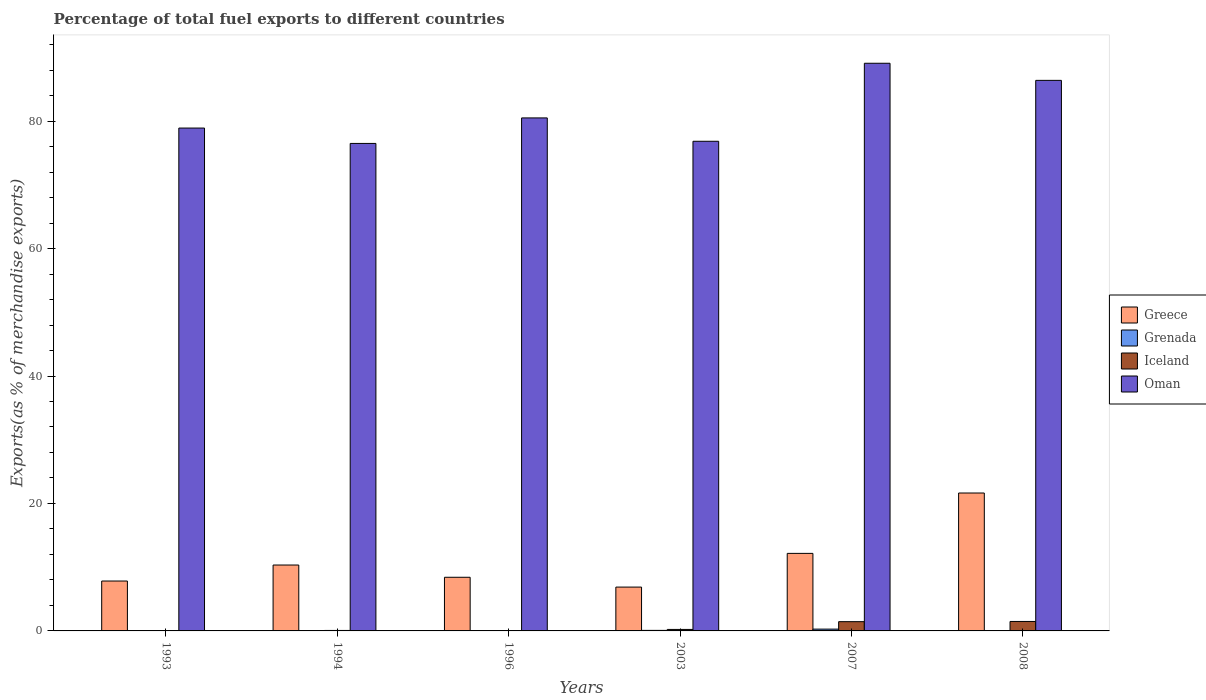Are the number of bars on each tick of the X-axis equal?
Keep it short and to the point. Yes. What is the percentage of exports to different countries in Iceland in 1994?
Make the answer very short. 0.07. Across all years, what is the maximum percentage of exports to different countries in Oman?
Offer a very short reply. 89.07. Across all years, what is the minimum percentage of exports to different countries in Iceland?
Give a very brief answer. 0.05. In which year was the percentage of exports to different countries in Oman maximum?
Keep it short and to the point. 2007. In which year was the percentage of exports to different countries in Grenada minimum?
Your answer should be very brief. 1993. What is the total percentage of exports to different countries in Greece in the graph?
Make the answer very short. 67.28. What is the difference between the percentage of exports to different countries in Grenada in 1994 and that in 2008?
Your answer should be very brief. -0.03. What is the difference between the percentage of exports to different countries in Grenada in 2007 and the percentage of exports to different countries in Greece in 1993?
Give a very brief answer. -7.55. What is the average percentage of exports to different countries in Grenada per year?
Ensure brevity in your answer.  0.07. In the year 1994, what is the difference between the percentage of exports to different countries in Greece and percentage of exports to different countries in Iceland?
Your answer should be very brief. 10.27. In how many years, is the percentage of exports to different countries in Grenada greater than 4 %?
Your response must be concise. 0. What is the ratio of the percentage of exports to different countries in Grenada in 1994 to that in 2008?
Offer a very short reply. 0.25. Is the difference between the percentage of exports to different countries in Greece in 2003 and 2007 greater than the difference between the percentage of exports to different countries in Iceland in 2003 and 2007?
Offer a terse response. No. What is the difference between the highest and the second highest percentage of exports to different countries in Grenada?
Make the answer very short. 0.2. What is the difference between the highest and the lowest percentage of exports to different countries in Greece?
Your response must be concise. 14.76. In how many years, is the percentage of exports to different countries in Grenada greater than the average percentage of exports to different countries in Grenada taken over all years?
Offer a terse response. 2. What does the 1st bar from the left in 1993 represents?
Provide a succinct answer. Greece. What does the 3rd bar from the right in 1993 represents?
Your response must be concise. Grenada. Is it the case that in every year, the sum of the percentage of exports to different countries in Grenada and percentage of exports to different countries in Iceland is greater than the percentage of exports to different countries in Greece?
Your answer should be compact. No. Are all the bars in the graph horizontal?
Make the answer very short. No. Are the values on the major ticks of Y-axis written in scientific E-notation?
Keep it short and to the point. No. Does the graph contain grids?
Your answer should be compact. No. Where does the legend appear in the graph?
Provide a short and direct response. Center right. What is the title of the graph?
Give a very brief answer. Percentage of total fuel exports to different countries. What is the label or title of the Y-axis?
Keep it short and to the point. Exports(as % of merchandise exports). What is the Exports(as % of merchandise exports) of Greece in 1993?
Your answer should be very brief. 7.83. What is the Exports(as % of merchandise exports) of Grenada in 1993?
Make the answer very short. 0. What is the Exports(as % of merchandise exports) in Iceland in 1993?
Provide a short and direct response. 0.05. What is the Exports(as % of merchandise exports) of Oman in 1993?
Provide a short and direct response. 78.91. What is the Exports(as % of merchandise exports) in Greece in 1994?
Give a very brief answer. 10.34. What is the Exports(as % of merchandise exports) of Grenada in 1994?
Keep it short and to the point. 0.01. What is the Exports(as % of merchandise exports) of Iceland in 1994?
Give a very brief answer. 0.07. What is the Exports(as % of merchandise exports) in Oman in 1994?
Provide a succinct answer. 76.5. What is the Exports(as % of merchandise exports) in Greece in 1996?
Your answer should be compact. 8.42. What is the Exports(as % of merchandise exports) in Grenada in 1996?
Ensure brevity in your answer.  0.03. What is the Exports(as % of merchandise exports) in Iceland in 1996?
Your response must be concise. 0.06. What is the Exports(as % of merchandise exports) in Oman in 1996?
Your answer should be very brief. 80.5. What is the Exports(as % of merchandise exports) of Greece in 2003?
Offer a very short reply. 6.88. What is the Exports(as % of merchandise exports) in Grenada in 2003?
Your answer should be very brief. 0.08. What is the Exports(as % of merchandise exports) in Iceland in 2003?
Keep it short and to the point. 0.23. What is the Exports(as % of merchandise exports) in Oman in 2003?
Your answer should be very brief. 76.83. What is the Exports(as % of merchandise exports) in Greece in 2007?
Offer a terse response. 12.17. What is the Exports(as % of merchandise exports) of Grenada in 2007?
Provide a succinct answer. 0.28. What is the Exports(as % of merchandise exports) of Iceland in 2007?
Offer a terse response. 1.45. What is the Exports(as % of merchandise exports) in Oman in 2007?
Make the answer very short. 89.07. What is the Exports(as % of merchandise exports) of Greece in 2008?
Make the answer very short. 21.64. What is the Exports(as % of merchandise exports) in Grenada in 2008?
Offer a terse response. 0.03. What is the Exports(as % of merchandise exports) in Iceland in 2008?
Your answer should be very brief. 1.48. What is the Exports(as % of merchandise exports) in Oman in 2008?
Your response must be concise. 86.39. Across all years, what is the maximum Exports(as % of merchandise exports) in Greece?
Keep it short and to the point. 21.64. Across all years, what is the maximum Exports(as % of merchandise exports) in Grenada?
Give a very brief answer. 0.28. Across all years, what is the maximum Exports(as % of merchandise exports) of Iceland?
Provide a short and direct response. 1.48. Across all years, what is the maximum Exports(as % of merchandise exports) of Oman?
Your response must be concise. 89.07. Across all years, what is the minimum Exports(as % of merchandise exports) in Greece?
Give a very brief answer. 6.88. Across all years, what is the minimum Exports(as % of merchandise exports) in Grenada?
Offer a terse response. 0. Across all years, what is the minimum Exports(as % of merchandise exports) in Iceland?
Give a very brief answer. 0.05. Across all years, what is the minimum Exports(as % of merchandise exports) in Oman?
Your answer should be very brief. 76.5. What is the total Exports(as % of merchandise exports) of Greece in the graph?
Give a very brief answer. 67.28. What is the total Exports(as % of merchandise exports) of Grenada in the graph?
Make the answer very short. 0.44. What is the total Exports(as % of merchandise exports) of Iceland in the graph?
Your answer should be very brief. 3.36. What is the total Exports(as % of merchandise exports) of Oman in the graph?
Your answer should be very brief. 488.2. What is the difference between the Exports(as % of merchandise exports) in Greece in 1993 and that in 1994?
Give a very brief answer. -2.51. What is the difference between the Exports(as % of merchandise exports) of Grenada in 1993 and that in 1994?
Give a very brief answer. -0.01. What is the difference between the Exports(as % of merchandise exports) in Iceland in 1993 and that in 1994?
Make the answer very short. -0.02. What is the difference between the Exports(as % of merchandise exports) in Oman in 1993 and that in 1994?
Make the answer very short. 2.41. What is the difference between the Exports(as % of merchandise exports) in Greece in 1993 and that in 1996?
Offer a terse response. -0.59. What is the difference between the Exports(as % of merchandise exports) in Grenada in 1993 and that in 1996?
Your answer should be very brief. -0.03. What is the difference between the Exports(as % of merchandise exports) in Iceland in 1993 and that in 1996?
Give a very brief answer. -0.01. What is the difference between the Exports(as % of merchandise exports) in Oman in 1993 and that in 1996?
Your answer should be very brief. -1.59. What is the difference between the Exports(as % of merchandise exports) of Greece in 1993 and that in 2003?
Your answer should be very brief. 0.95. What is the difference between the Exports(as % of merchandise exports) in Grenada in 1993 and that in 2003?
Your response must be concise. -0.08. What is the difference between the Exports(as % of merchandise exports) of Iceland in 1993 and that in 2003?
Offer a very short reply. -0.18. What is the difference between the Exports(as % of merchandise exports) in Oman in 1993 and that in 2003?
Ensure brevity in your answer.  2.07. What is the difference between the Exports(as % of merchandise exports) in Greece in 1993 and that in 2007?
Provide a succinct answer. -4.34. What is the difference between the Exports(as % of merchandise exports) in Grenada in 1993 and that in 2007?
Your response must be concise. -0.28. What is the difference between the Exports(as % of merchandise exports) in Iceland in 1993 and that in 2007?
Keep it short and to the point. -1.4. What is the difference between the Exports(as % of merchandise exports) of Oman in 1993 and that in 2007?
Provide a succinct answer. -10.17. What is the difference between the Exports(as % of merchandise exports) of Greece in 1993 and that in 2008?
Provide a succinct answer. -13.81. What is the difference between the Exports(as % of merchandise exports) of Grenada in 1993 and that in 2008?
Your response must be concise. -0.03. What is the difference between the Exports(as % of merchandise exports) of Iceland in 1993 and that in 2008?
Give a very brief answer. -1.43. What is the difference between the Exports(as % of merchandise exports) in Oman in 1993 and that in 2008?
Offer a very short reply. -7.48. What is the difference between the Exports(as % of merchandise exports) in Greece in 1994 and that in 1996?
Provide a succinct answer. 1.92. What is the difference between the Exports(as % of merchandise exports) of Grenada in 1994 and that in 1996?
Your answer should be compact. -0.02. What is the difference between the Exports(as % of merchandise exports) of Iceland in 1994 and that in 1996?
Give a very brief answer. 0.01. What is the difference between the Exports(as % of merchandise exports) of Oman in 1994 and that in 1996?
Your answer should be very brief. -4. What is the difference between the Exports(as % of merchandise exports) of Greece in 1994 and that in 2003?
Offer a very short reply. 3.46. What is the difference between the Exports(as % of merchandise exports) in Grenada in 1994 and that in 2003?
Give a very brief answer. -0.08. What is the difference between the Exports(as % of merchandise exports) in Iceland in 1994 and that in 2003?
Your answer should be very brief. -0.16. What is the difference between the Exports(as % of merchandise exports) in Oman in 1994 and that in 2003?
Your answer should be compact. -0.34. What is the difference between the Exports(as % of merchandise exports) in Greece in 1994 and that in 2007?
Provide a succinct answer. -1.83. What is the difference between the Exports(as % of merchandise exports) in Grenada in 1994 and that in 2007?
Your answer should be very brief. -0.27. What is the difference between the Exports(as % of merchandise exports) in Iceland in 1994 and that in 2007?
Provide a succinct answer. -1.38. What is the difference between the Exports(as % of merchandise exports) in Oman in 1994 and that in 2007?
Your answer should be compact. -12.58. What is the difference between the Exports(as % of merchandise exports) of Greece in 1994 and that in 2008?
Your answer should be very brief. -11.3. What is the difference between the Exports(as % of merchandise exports) of Grenada in 1994 and that in 2008?
Give a very brief answer. -0.03. What is the difference between the Exports(as % of merchandise exports) in Iceland in 1994 and that in 2008?
Ensure brevity in your answer.  -1.41. What is the difference between the Exports(as % of merchandise exports) in Oman in 1994 and that in 2008?
Offer a very short reply. -9.89. What is the difference between the Exports(as % of merchandise exports) in Greece in 1996 and that in 2003?
Provide a succinct answer. 1.54. What is the difference between the Exports(as % of merchandise exports) of Grenada in 1996 and that in 2003?
Offer a terse response. -0.06. What is the difference between the Exports(as % of merchandise exports) of Iceland in 1996 and that in 2003?
Ensure brevity in your answer.  -0.17. What is the difference between the Exports(as % of merchandise exports) of Oman in 1996 and that in 2003?
Your answer should be very brief. 3.67. What is the difference between the Exports(as % of merchandise exports) of Greece in 1996 and that in 2007?
Your response must be concise. -3.75. What is the difference between the Exports(as % of merchandise exports) of Grenada in 1996 and that in 2007?
Ensure brevity in your answer.  -0.25. What is the difference between the Exports(as % of merchandise exports) in Iceland in 1996 and that in 2007?
Your answer should be very brief. -1.39. What is the difference between the Exports(as % of merchandise exports) in Oman in 1996 and that in 2007?
Give a very brief answer. -8.58. What is the difference between the Exports(as % of merchandise exports) in Greece in 1996 and that in 2008?
Your answer should be compact. -13.22. What is the difference between the Exports(as % of merchandise exports) of Grenada in 1996 and that in 2008?
Your answer should be very brief. -0.01. What is the difference between the Exports(as % of merchandise exports) of Iceland in 1996 and that in 2008?
Offer a very short reply. -1.42. What is the difference between the Exports(as % of merchandise exports) of Oman in 1996 and that in 2008?
Provide a short and direct response. -5.89. What is the difference between the Exports(as % of merchandise exports) of Greece in 2003 and that in 2007?
Your answer should be very brief. -5.29. What is the difference between the Exports(as % of merchandise exports) in Grenada in 2003 and that in 2007?
Ensure brevity in your answer.  -0.2. What is the difference between the Exports(as % of merchandise exports) in Iceland in 2003 and that in 2007?
Your answer should be compact. -1.22. What is the difference between the Exports(as % of merchandise exports) of Oman in 2003 and that in 2007?
Keep it short and to the point. -12.24. What is the difference between the Exports(as % of merchandise exports) in Greece in 2003 and that in 2008?
Your answer should be compact. -14.76. What is the difference between the Exports(as % of merchandise exports) of Grenada in 2003 and that in 2008?
Provide a succinct answer. 0.05. What is the difference between the Exports(as % of merchandise exports) of Iceland in 2003 and that in 2008?
Your response must be concise. -1.25. What is the difference between the Exports(as % of merchandise exports) of Oman in 2003 and that in 2008?
Provide a short and direct response. -9.56. What is the difference between the Exports(as % of merchandise exports) of Greece in 2007 and that in 2008?
Make the answer very short. -9.47. What is the difference between the Exports(as % of merchandise exports) of Grenada in 2007 and that in 2008?
Offer a very short reply. 0.25. What is the difference between the Exports(as % of merchandise exports) of Iceland in 2007 and that in 2008?
Your answer should be very brief. -0.03. What is the difference between the Exports(as % of merchandise exports) of Oman in 2007 and that in 2008?
Offer a very short reply. 2.69. What is the difference between the Exports(as % of merchandise exports) in Greece in 1993 and the Exports(as % of merchandise exports) in Grenada in 1994?
Ensure brevity in your answer.  7.82. What is the difference between the Exports(as % of merchandise exports) in Greece in 1993 and the Exports(as % of merchandise exports) in Iceland in 1994?
Offer a very short reply. 7.76. What is the difference between the Exports(as % of merchandise exports) of Greece in 1993 and the Exports(as % of merchandise exports) of Oman in 1994?
Your response must be concise. -68.67. What is the difference between the Exports(as % of merchandise exports) of Grenada in 1993 and the Exports(as % of merchandise exports) of Iceland in 1994?
Your answer should be compact. -0.07. What is the difference between the Exports(as % of merchandise exports) of Grenada in 1993 and the Exports(as % of merchandise exports) of Oman in 1994?
Offer a terse response. -76.49. What is the difference between the Exports(as % of merchandise exports) of Iceland in 1993 and the Exports(as % of merchandise exports) of Oman in 1994?
Your answer should be very brief. -76.44. What is the difference between the Exports(as % of merchandise exports) of Greece in 1993 and the Exports(as % of merchandise exports) of Grenada in 1996?
Keep it short and to the point. 7.8. What is the difference between the Exports(as % of merchandise exports) of Greece in 1993 and the Exports(as % of merchandise exports) of Iceland in 1996?
Offer a very short reply. 7.77. What is the difference between the Exports(as % of merchandise exports) in Greece in 1993 and the Exports(as % of merchandise exports) in Oman in 1996?
Make the answer very short. -72.67. What is the difference between the Exports(as % of merchandise exports) of Grenada in 1993 and the Exports(as % of merchandise exports) of Iceland in 1996?
Offer a very short reply. -0.06. What is the difference between the Exports(as % of merchandise exports) of Grenada in 1993 and the Exports(as % of merchandise exports) of Oman in 1996?
Your answer should be very brief. -80.5. What is the difference between the Exports(as % of merchandise exports) in Iceland in 1993 and the Exports(as % of merchandise exports) in Oman in 1996?
Provide a short and direct response. -80.45. What is the difference between the Exports(as % of merchandise exports) of Greece in 1993 and the Exports(as % of merchandise exports) of Grenada in 2003?
Provide a short and direct response. 7.75. What is the difference between the Exports(as % of merchandise exports) in Greece in 1993 and the Exports(as % of merchandise exports) in Iceland in 2003?
Give a very brief answer. 7.59. What is the difference between the Exports(as % of merchandise exports) of Greece in 1993 and the Exports(as % of merchandise exports) of Oman in 2003?
Keep it short and to the point. -69. What is the difference between the Exports(as % of merchandise exports) of Grenada in 1993 and the Exports(as % of merchandise exports) of Iceland in 2003?
Your answer should be compact. -0.23. What is the difference between the Exports(as % of merchandise exports) in Grenada in 1993 and the Exports(as % of merchandise exports) in Oman in 2003?
Your response must be concise. -76.83. What is the difference between the Exports(as % of merchandise exports) in Iceland in 1993 and the Exports(as % of merchandise exports) in Oman in 2003?
Provide a short and direct response. -76.78. What is the difference between the Exports(as % of merchandise exports) in Greece in 1993 and the Exports(as % of merchandise exports) in Grenada in 2007?
Give a very brief answer. 7.55. What is the difference between the Exports(as % of merchandise exports) in Greece in 1993 and the Exports(as % of merchandise exports) in Iceland in 2007?
Offer a very short reply. 6.38. What is the difference between the Exports(as % of merchandise exports) of Greece in 1993 and the Exports(as % of merchandise exports) of Oman in 2007?
Provide a short and direct response. -81.25. What is the difference between the Exports(as % of merchandise exports) of Grenada in 1993 and the Exports(as % of merchandise exports) of Iceland in 2007?
Make the answer very short. -1.45. What is the difference between the Exports(as % of merchandise exports) of Grenada in 1993 and the Exports(as % of merchandise exports) of Oman in 2007?
Provide a short and direct response. -89.07. What is the difference between the Exports(as % of merchandise exports) of Iceland in 1993 and the Exports(as % of merchandise exports) of Oman in 2007?
Your answer should be very brief. -89.02. What is the difference between the Exports(as % of merchandise exports) of Greece in 1993 and the Exports(as % of merchandise exports) of Grenada in 2008?
Your response must be concise. 7.8. What is the difference between the Exports(as % of merchandise exports) of Greece in 1993 and the Exports(as % of merchandise exports) of Iceland in 2008?
Make the answer very short. 6.35. What is the difference between the Exports(as % of merchandise exports) in Greece in 1993 and the Exports(as % of merchandise exports) in Oman in 2008?
Your answer should be very brief. -78.56. What is the difference between the Exports(as % of merchandise exports) in Grenada in 1993 and the Exports(as % of merchandise exports) in Iceland in 2008?
Offer a very short reply. -1.48. What is the difference between the Exports(as % of merchandise exports) of Grenada in 1993 and the Exports(as % of merchandise exports) of Oman in 2008?
Ensure brevity in your answer.  -86.39. What is the difference between the Exports(as % of merchandise exports) in Iceland in 1993 and the Exports(as % of merchandise exports) in Oman in 2008?
Give a very brief answer. -86.34. What is the difference between the Exports(as % of merchandise exports) of Greece in 1994 and the Exports(as % of merchandise exports) of Grenada in 1996?
Make the answer very short. 10.31. What is the difference between the Exports(as % of merchandise exports) of Greece in 1994 and the Exports(as % of merchandise exports) of Iceland in 1996?
Your answer should be very brief. 10.28. What is the difference between the Exports(as % of merchandise exports) of Greece in 1994 and the Exports(as % of merchandise exports) of Oman in 1996?
Your answer should be very brief. -70.16. What is the difference between the Exports(as % of merchandise exports) of Grenada in 1994 and the Exports(as % of merchandise exports) of Iceland in 1996?
Make the answer very short. -0.05. What is the difference between the Exports(as % of merchandise exports) in Grenada in 1994 and the Exports(as % of merchandise exports) in Oman in 1996?
Make the answer very short. -80.49. What is the difference between the Exports(as % of merchandise exports) in Iceland in 1994 and the Exports(as % of merchandise exports) in Oman in 1996?
Your response must be concise. -80.42. What is the difference between the Exports(as % of merchandise exports) of Greece in 1994 and the Exports(as % of merchandise exports) of Grenada in 2003?
Provide a succinct answer. 10.26. What is the difference between the Exports(as % of merchandise exports) in Greece in 1994 and the Exports(as % of merchandise exports) in Iceland in 2003?
Your response must be concise. 10.11. What is the difference between the Exports(as % of merchandise exports) in Greece in 1994 and the Exports(as % of merchandise exports) in Oman in 2003?
Your answer should be compact. -66.49. What is the difference between the Exports(as % of merchandise exports) in Grenada in 1994 and the Exports(as % of merchandise exports) in Iceland in 2003?
Give a very brief answer. -0.23. What is the difference between the Exports(as % of merchandise exports) in Grenada in 1994 and the Exports(as % of merchandise exports) in Oman in 2003?
Your response must be concise. -76.83. What is the difference between the Exports(as % of merchandise exports) of Iceland in 1994 and the Exports(as % of merchandise exports) of Oman in 2003?
Give a very brief answer. -76.76. What is the difference between the Exports(as % of merchandise exports) of Greece in 1994 and the Exports(as % of merchandise exports) of Grenada in 2007?
Your response must be concise. 10.06. What is the difference between the Exports(as % of merchandise exports) in Greece in 1994 and the Exports(as % of merchandise exports) in Iceland in 2007?
Your answer should be compact. 8.89. What is the difference between the Exports(as % of merchandise exports) in Greece in 1994 and the Exports(as % of merchandise exports) in Oman in 2007?
Keep it short and to the point. -78.73. What is the difference between the Exports(as % of merchandise exports) in Grenada in 1994 and the Exports(as % of merchandise exports) in Iceland in 2007?
Ensure brevity in your answer.  -1.45. What is the difference between the Exports(as % of merchandise exports) in Grenada in 1994 and the Exports(as % of merchandise exports) in Oman in 2007?
Offer a very short reply. -89.07. What is the difference between the Exports(as % of merchandise exports) of Iceland in 1994 and the Exports(as % of merchandise exports) of Oman in 2007?
Offer a terse response. -89. What is the difference between the Exports(as % of merchandise exports) of Greece in 1994 and the Exports(as % of merchandise exports) of Grenada in 2008?
Offer a terse response. 10.31. What is the difference between the Exports(as % of merchandise exports) in Greece in 1994 and the Exports(as % of merchandise exports) in Iceland in 2008?
Your answer should be compact. 8.86. What is the difference between the Exports(as % of merchandise exports) in Greece in 1994 and the Exports(as % of merchandise exports) in Oman in 2008?
Provide a succinct answer. -76.05. What is the difference between the Exports(as % of merchandise exports) in Grenada in 1994 and the Exports(as % of merchandise exports) in Iceland in 2008?
Provide a short and direct response. -1.47. What is the difference between the Exports(as % of merchandise exports) of Grenada in 1994 and the Exports(as % of merchandise exports) of Oman in 2008?
Provide a short and direct response. -86.38. What is the difference between the Exports(as % of merchandise exports) of Iceland in 1994 and the Exports(as % of merchandise exports) of Oman in 2008?
Give a very brief answer. -86.32. What is the difference between the Exports(as % of merchandise exports) in Greece in 1996 and the Exports(as % of merchandise exports) in Grenada in 2003?
Ensure brevity in your answer.  8.34. What is the difference between the Exports(as % of merchandise exports) in Greece in 1996 and the Exports(as % of merchandise exports) in Iceland in 2003?
Your answer should be very brief. 8.18. What is the difference between the Exports(as % of merchandise exports) in Greece in 1996 and the Exports(as % of merchandise exports) in Oman in 2003?
Provide a short and direct response. -68.41. What is the difference between the Exports(as % of merchandise exports) in Grenada in 1996 and the Exports(as % of merchandise exports) in Iceland in 2003?
Your response must be concise. -0.21. What is the difference between the Exports(as % of merchandise exports) of Grenada in 1996 and the Exports(as % of merchandise exports) of Oman in 2003?
Offer a very short reply. -76.81. What is the difference between the Exports(as % of merchandise exports) in Iceland in 1996 and the Exports(as % of merchandise exports) in Oman in 2003?
Offer a very short reply. -76.77. What is the difference between the Exports(as % of merchandise exports) of Greece in 1996 and the Exports(as % of merchandise exports) of Grenada in 2007?
Your answer should be compact. 8.14. What is the difference between the Exports(as % of merchandise exports) of Greece in 1996 and the Exports(as % of merchandise exports) of Iceland in 2007?
Your answer should be very brief. 6.97. What is the difference between the Exports(as % of merchandise exports) in Greece in 1996 and the Exports(as % of merchandise exports) in Oman in 2007?
Your answer should be compact. -80.66. What is the difference between the Exports(as % of merchandise exports) in Grenada in 1996 and the Exports(as % of merchandise exports) in Iceland in 2007?
Your answer should be compact. -1.43. What is the difference between the Exports(as % of merchandise exports) in Grenada in 1996 and the Exports(as % of merchandise exports) in Oman in 2007?
Provide a succinct answer. -89.05. What is the difference between the Exports(as % of merchandise exports) in Iceland in 1996 and the Exports(as % of merchandise exports) in Oman in 2007?
Provide a succinct answer. -89.01. What is the difference between the Exports(as % of merchandise exports) of Greece in 1996 and the Exports(as % of merchandise exports) of Grenada in 2008?
Make the answer very short. 8.39. What is the difference between the Exports(as % of merchandise exports) of Greece in 1996 and the Exports(as % of merchandise exports) of Iceland in 2008?
Your answer should be very brief. 6.94. What is the difference between the Exports(as % of merchandise exports) of Greece in 1996 and the Exports(as % of merchandise exports) of Oman in 2008?
Keep it short and to the point. -77.97. What is the difference between the Exports(as % of merchandise exports) of Grenada in 1996 and the Exports(as % of merchandise exports) of Iceland in 2008?
Provide a short and direct response. -1.46. What is the difference between the Exports(as % of merchandise exports) in Grenada in 1996 and the Exports(as % of merchandise exports) in Oman in 2008?
Give a very brief answer. -86.36. What is the difference between the Exports(as % of merchandise exports) in Iceland in 1996 and the Exports(as % of merchandise exports) in Oman in 2008?
Provide a short and direct response. -86.33. What is the difference between the Exports(as % of merchandise exports) of Greece in 2003 and the Exports(as % of merchandise exports) of Grenada in 2007?
Your response must be concise. 6.6. What is the difference between the Exports(as % of merchandise exports) in Greece in 2003 and the Exports(as % of merchandise exports) in Iceland in 2007?
Ensure brevity in your answer.  5.42. What is the difference between the Exports(as % of merchandise exports) in Greece in 2003 and the Exports(as % of merchandise exports) in Oman in 2007?
Make the answer very short. -82.2. What is the difference between the Exports(as % of merchandise exports) in Grenada in 2003 and the Exports(as % of merchandise exports) in Iceland in 2007?
Offer a terse response. -1.37. What is the difference between the Exports(as % of merchandise exports) in Grenada in 2003 and the Exports(as % of merchandise exports) in Oman in 2007?
Make the answer very short. -88.99. What is the difference between the Exports(as % of merchandise exports) of Iceland in 2003 and the Exports(as % of merchandise exports) of Oman in 2007?
Ensure brevity in your answer.  -88.84. What is the difference between the Exports(as % of merchandise exports) of Greece in 2003 and the Exports(as % of merchandise exports) of Grenada in 2008?
Ensure brevity in your answer.  6.84. What is the difference between the Exports(as % of merchandise exports) in Greece in 2003 and the Exports(as % of merchandise exports) in Iceland in 2008?
Your answer should be very brief. 5.4. What is the difference between the Exports(as % of merchandise exports) in Greece in 2003 and the Exports(as % of merchandise exports) in Oman in 2008?
Your response must be concise. -79.51. What is the difference between the Exports(as % of merchandise exports) of Grenada in 2003 and the Exports(as % of merchandise exports) of Iceland in 2008?
Make the answer very short. -1.4. What is the difference between the Exports(as % of merchandise exports) of Grenada in 2003 and the Exports(as % of merchandise exports) of Oman in 2008?
Ensure brevity in your answer.  -86.31. What is the difference between the Exports(as % of merchandise exports) of Iceland in 2003 and the Exports(as % of merchandise exports) of Oman in 2008?
Give a very brief answer. -86.15. What is the difference between the Exports(as % of merchandise exports) of Greece in 2007 and the Exports(as % of merchandise exports) of Grenada in 2008?
Offer a very short reply. 12.13. What is the difference between the Exports(as % of merchandise exports) of Greece in 2007 and the Exports(as % of merchandise exports) of Iceland in 2008?
Provide a succinct answer. 10.68. What is the difference between the Exports(as % of merchandise exports) in Greece in 2007 and the Exports(as % of merchandise exports) in Oman in 2008?
Provide a short and direct response. -74.22. What is the difference between the Exports(as % of merchandise exports) of Grenada in 2007 and the Exports(as % of merchandise exports) of Iceland in 2008?
Your response must be concise. -1.2. What is the difference between the Exports(as % of merchandise exports) in Grenada in 2007 and the Exports(as % of merchandise exports) in Oman in 2008?
Offer a very short reply. -86.11. What is the difference between the Exports(as % of merchandise exports) in Iceland in 2007 and the Exports(as % of merchandise exports) in Oman in 2008?
Provide a succinct answer. -84.94. What is the average Exports(as % of merchandise exports) in Greece per year?
Make the answer very short. 11.21. What is the average Exports(as % of merchandise exports) of Grenada per year?
Your answer should be very brief. 0.07. What is the average Exports(as % of merchandise exports) of Iceland per year?
Keep it short and to the point. 0.56. What is the average Exports(as % of merchandise exports) in Oman per year?
Offer a very short reply. 81.37. In the year 1993, what is the difference between the Exports(as % of merchandise exports) of Greece and Exports(as % of merchandise exports) of Grenada?
Ensure brevity in your answer.  7.83. In the year 1993, what is the difference between the Exports(as % of merchandise exports) in Greece and Exports(as % of merchandise exports) in Iceland?
Make the answer very short. 7.78. In the year 1993, what is the difference between the Exports(as % of merchandise exports) in Greece and Exports(as % of merchandise exports) in Oman?
Ensure brevity in your answer.  -71.08. In the year 1993, what is the difference between the Exports(as % of merchandise exports) of Grenada and Exports(as % of merchandise exports) of Iceland?
Keep it short and to the point. -0.05. In the year 1993, what is the difference between the Exports(as % of merchandise exports) in Grenada and Exports(as % of merchandise exports) in Oman?
Provide a short and direct response. -78.91. In the year 1993, what is the difference between the Exports(as % of merchandise exports) in Iceland and Exports(as % of merchandise exports) in Oman?
Provide a short and direct response. -78.86. In the year 1994, what is the difference between the Exports(as % of merchandise exports) in Greece and Exports(as % of merchandise exports) in Grenada?
Keep it short and to the point. 10.33. In the year 1994, what is the difference between the Exports(as % of merchandise exports) of Greece and Exports(as % of merchandise exports) of Iceland?
Give a very brief answer. 10.27. In the year 1994, what is the difference between the Exports(as % of merchandise exports) in Greece and Exports(as % of merchandise exports) in Oman?
Provide a short and direct response. -66.15. In the year 1994, what is the difference between the Exports(as % of merchandise exports) in Grenada and Exports(as % of merchandise exports) in Iceland?
Give a very brief answer. -0.07. In the year 1994, what is the difference between the Exports(as % of merchandise exports) in Grenada and Exports(as % of merchandise exports) in Oman?
Offer a terse response. -76.49. In the year 1994, what is the difference between the Exports(as % of merchandise exports) of Iceland and Exports(as % of merchandise exports) of Oman?
Provide a short and direct response. -76.42. In the year 1996, what is the difference between the Exports(as % of merchandise exports) of Greece and Exports(as % of merchandise exports) of Grenada?
Give a very brief answer. 8.39. In the year 1996, what is the difference between the Exports(as % of merchandise exports) of Greece and Exports(as % of merchandise exports) of Iceland?
Make the answer very short. 8.36. In the year 1996, what is the difference between the Exports(as % of merchandise exports) of Greece and Exports(as % of merchandise exports) of Oman?
Ensure brevity in your answer.  -72.08. In the year 1996, what is the difference between the Exports(as % of merchandise exports) of Grenada and Exports(as % of merchandise exports) of Iceland?
Your response must be concise. -0.03. In the year 1996, what is the difference between the Exports(as % of merchandise exports) of Grenada and Exports(as % of merchandise exports) of Oman?
Keep it short and to the point. -80.47. In the year 1996, what is the difference between the Exports(as % of merchandise exports) in Iceland and Exports(as % of merchandise exports) in Oman?
Offer a very short reply. -80.44. In the year 2003, what is the difference between the Exports(as % of merchandise exports) of Greece and Exports(as % of merchandise exports) of Grenada?
Keep it short and to the point. 6.79. In the year 2003, what is the difference between the Exports(as % of merchandise exports) in Greece and Exports(as % of merchandise exports) in Iceland?
Your response must be concise. 6.64. In the year 2003, what is the difference between the Exports(as % of merchandise exports) in Greece and Exports(as % of merchandise exports) in Oman?
Your answer should be very brief. -69.96. In the year 2003, what is the difference between the Exports(as % of merchandise exports) in Grenada and Exports(as % of merchandise exports) in Iceland?
Ensure brevity in your answer.  -0.15. In the year 2003, what is the difference between the Exports(as % of merchandise exports) in Grenada and Exports(as % of merchandise exports) in Oman?
Your answer should be very brief. -76.75. In the year 2003, what is the difference between the Exports(as % of merchandise exports) in Iceland and Exports(as % of merchandise exports) in Oman?
Provide a short and direct response. -76.6. In the year 2007, what is the difference between the Exports(as % of merchandise exports) of Greece and Exports(as % of merchandise exports) of Grenada?
Make the answer very short. 11.88. In the year 2007, what is the difference between the Exports(as % of merchandise exports) of Greece and Exports(as % of merchandise exports) of Iceland?
Make the answer very short. 10.71. In the year 2007, what is the difference between the Exports(as % of merchandise exports) of Greece and Exports(as % of merchandise exports) of Oman?
Provide a succinct answer. -76.91. In the year 2007, what is the difference between the Exports(as % of merchandise exports) of Grenada and Exports(as % of merchandise exports) of Iceland?
Provide a succinct answer. -1.17. In the year 2007, what is the difference between the Exports(as % of merchandise exports) of Grenada and Exports(as % of merchandise exports) of Oman?
Provide a short and direct response. -88.79. In the year 2007, what is the difference between the Exports(as % of merchandise exports) in Iceland and Exports(as % of merchandise exports) in Oman?
Offer a terse response. -87.62. In the year 2008, what is the difference between the Exports(as % of merchandise exports) of Greece and Exports(as % of merchandise exports) of Grenada?
Your answer should be compact. 21.61. In the year 2008, what is the difference between the Exports(as % of merchandise exports) of Greece and Exports(as % of merchandise exports) of Iceland?
Your response must be concise. 20.16. In the year 2008, what is the difference between the Exports(as % of merchandise exports) in Greece and Exports(as % of merchandise exports) in Oman?
Provide a short and direct response. -64.75. In the year 2008, what is the difference between the Exports(as % of merchandise exports) in Grenada and Exports(as % of merchandise exports) in Iceland?
Your answer should be very brief. -1.45. In the year 2008, what is the difference between the Exports(as % of merchandise exports) in Grenada and Exports(as % of merchandise exports) in Oman?
Keep it short and to the point. -86.36. In the year 2008, what is the difference between the Exports(as % of merchandise exports) of Iceland and Exports(as % of merchandise exports) of Oman?
Offer a very short reply. -84.91. What is the ratio of the Exports(as % of merchandise exports) in Greece in 1993 to that in 1994?
Give a very brief answer. 0.76. What is the ratio of the Exports(as % of merchandise exports) of Grenada in 1993 to that in 1994?
Make the answer very short. 0.06. What is the ratio of the Exports(as % of merchandise exports) in Iceland in 1993 to that in 1994?
Offer a very short reply. 0.69. What is the ratio of the Exports(as % of merchandise exports) of Oman in 1993 to that in 1994?
Give a very brief answer. 1.03. What is the ratio of the Exports(as % of merchandise exports) in Greece in 1993 to that in 1996?
Provide a succinct answer. 0.93. What is the ratio of the Exports(as % of merchandise exports) of Grenada in 1993 to that in 1996?
Provide a succinct answer. 0.02. What is the ratio of the Exports(as % of merchandise exports) of Iceland in 1993 to that in 1996?
Your answer should be compact. 0.84. What is the ratio of the Exports(as % of merchandise exports) in Oman in 1993 to that in 1996?
Make the answer very short. 0.98. What is the ratio of the Exports(as % of merchandise exports) of Greece in 1993 to that in 2003?
Ensure brevity in your answer.  1.14. What is the ratio of the Exports(as % of merchandise exports) of Grenada in 1993 to that in 2003?
Offer a very short reply. 0.01. What is the ratio of the Exports(as % of merchandise exports) of Iceland in 1993 to that in 2003?
Provide a short and direct response. 0.22. What is the ratio of the Exports(as % of merchandise exports) of Greece in 1993 to that in 2007?
Your response must be concise. 0.64. What is the ratio of the Exports(as % of merchandise exports) in Grenada in 1993 to that in 2007?
Give a very brief answer. 0. What is the ratio of the Exports(as % of merchandise exports) of Iceland in 1993 to that in 2007?
Provide a succinct answer. 0.04. What is the ratio of the Exports(as % of merchandise exports) in Oman in 1993 to that in 2007?
Give a very brief answer. 0.89. What is the ratio of the Exports(as % of merchandise exports) of Greece in 1993 to that in 2008?
Provide a succinct answer. 0.36. What is the ratio of the Exports(as % of merchandise exports) in Grenada in 1993 to that in 2008?
Give a very brief answer. 0.01. What is the ratio of the Exports(as % of merchandise exports) of Iceland in 1993 to that in 2008?
Offer a very short reply. 0.03. What is the ratio of the Exports(as % of merchandise exports) of Oman in 1993 to that in 2008?
Provide a short and direct response. 0.91. What is the ratio of the Exports(as % of merchandise exports) in Greece in 1994 to that in 1996?
Keep it short and to the point. 1.23. What is the ratio of the Exports(as % of merchandise exports) in Grenada in 1994 to that in 1996?
Keep it short and to the point. 0.3. What is the ratio of the Exports(as % of merchandise exports) in Iceland in 1994 to that in 1996?
Provide a succinct answer. 1.21. What is the ratio of the Exports(as % of merchandise exports) in Oman in 1994 to that in 1996?
Your response must be concise. 0.95. What is the ratio of the Exports(as % of merchandise exports) of Greece in 1994 to that in 2003?
Your response must be concise. 1.5. What is the ratio of the Exports(as % of merchandise exports) of Grenada in 1994 to that in 2003?
Offer a very short reply. 0.1. What is the ratio of the Exports(as % of merchandise exports) of Iceland in 1994 to that in 2003?
Your answer should be very brief. 0.31. What is the ratio of the Exports(as % of merchandise exports) in Oman in 1994 to that in 2003?
Your response must be concise. 1. What is the ratio of the Exports(as % of merchandise exports) of Greece in 1994 to that in 2007?
Your response must be concise. 0.85. What is the ratio of the Exports(as % of merchandise exports) in Iceland in 1994 to that in 2007?
Offer a very short reply. 0.05. What is the ratio of the Exports(as % of merchandise exports) of Oman in 1994 to that in 2007?
Your answer should be very brief. 0.86. What is the ratio of the Exports(as % of merchandise exports) in Greece in 1994 to that in 2008?
Give a very brief answer. 0.48. What is the ratio of the Exports(as % of merchandise exports) of Grenada in 1994 to that in 2008?
Make the answer very short. 0.25. What is the ratio of the Exports(as % of merchandise exports) of Iceland in 1994 to that in 2008?
Your answer should be very brief. 0.05. What is the ratio of the Exports(as % of merchandise exports) of Oman in 1994 to that in 2008?
Keep it short and to the point. 0.89. What is the ratio of the Exports(as % of merchandise exports) in Greece in 1996 to that in 2003?
Provide a short and direct response. 1.22. What is the ratio of the Exports(as % of merchandise exports) in Grenada in 1996 to that in 2003?
Offer a terse response. 0.33. What is the ratio of the Exports(as % of merchandise exports) in Iceland in 1996 to that in 2003?
Your response must be concise. 0.26. What is the ratio of the Exports(as % of merchandise exports) in Oman in 1996 to that in 2003?
Your answer should be very brief. 1.05. What is the ratio of the Exports(as % of merchandise exports) of Greece in 1996 to that in 2007?
Give a very brief answer. 0.69. What is the ratio of the Exports(as % of merchandise exports) in Grenada in 1996 to that in 2007?
Provide a short and direct response. 0.1. What is the ratio of the Exports(as % of merchandise exports) in Iceland in 1996 to that in 2007?
Give a very brief answer. 0.04. What is the ratio of the Exports(as % of merchandise exports) in Oman in 1996 to that in 2007?
Your answer should be very brief. 0.9. What is the ratio of the Exports(as % of merchandise exports) of Greece in 1996 to that in 2008?
Offer a very short reply. 0.39. What is the ratio of the Exports(as % of merchandise exports) in Grenada in 1996 to that in 2008?
Your answer should be compact. 0.82. What is the ratio of the Exports(as % of merchandise exports) in Iceland in 1996 to that in 2008?
Your answer should be compact. 0.04. What is the ratio of the Exports(as % of merchandise exports) in Oman in 1996 to that in 2008?
Provide a short and direct response. 0.93. What is the ratio of the Exports(as % of merchandise exports) of Greece in 2003 to that in 2007?
Ensure brevity in your answer.  0.57. What is the ratio of the Exports(as % of merchandise exports) in Grenada in 2003 to that in 2007?
Ensure brevity in your answer.  0.3. What is the ratio of the Exports(as % of merchandise exports) in Iceland in 2003 to that in 2007?
Ensure brevity in your answer.  0.16. What is the ratio of the Exports(as % of merchandise exports) in Oman in 2003 to that in 2007?
Offer a very short reply. 0.86. What is the ratio of the Exports(as % of merchandise exports) of Greece in 2003 to that in 2008?
Your response must be concise. 0.32. What is the ratio of the Exports(as % of merchandise exports) in Grenada in 2003 to that in 2008?
Your answer should be very brief. 2.48. What is the ratio of the Exports(as % of merchandise exports) in Iceland in 2003 to that in 2008?
Your response must be concise. 0.16. What is the ratio of the Exports(as % of merchandise exports) of Oman in 2003 to that in 2008?
Your answer should be very brief. 0.89. What is the ratio of the Exports(as % of merchandise exports) of Greece in 2007 to that in 2008?
Offer a terse response. 0.56. What is the ratio of the Exports(as % of merchandise exports) of Grenada in 2007 to that in 2008?
Provide a succinct answer. 8.36. What is the ratio of the Exports(as % of merchandise exports) of Iceland in 2007 to that in 2008?
Offer a terse response. 0.98. What is the ratio of the Exports(as % of merchandise exports) in Oman in 2007 to that in 2008?
Provide a short and direct response. 1.03. What is the difference between the highest and the second highest Exports(as % of merchandise exports) of Greece?
Keep it short and to the point. 9.47. What is the difference between the highest and the second highest Exports(as % of merchandise exports) in Grenada?
Keep it short and to the point. 0.2. What is the difference between the highest and the second highest Exports(as % of merchandise exports) in Iceland?
Your answer should be compact. 0.03. What is the difference between the highest and the second highest Exports(as % of merchandise exports) of Oman?
Your answer should be compact. 2.69. What is the difference between the highest and the lowest Exports(as % of merchandise exports) of Greece?
Your answer should be very brief. 14.76. What is the difference between the highest and the lowest Exports(as % of merchandise exports) in Grenada?
Give a very brief answer. 0.28. What is the difference between the highest and the lowest Exports(as % of merchandise exports) of Iceland?
Provide a short and direct response. 1.43. What is the difference between the highest and the lowest Exports(as % of merchandise exports) of Oman?
Your answer should be compact. 12.58. 